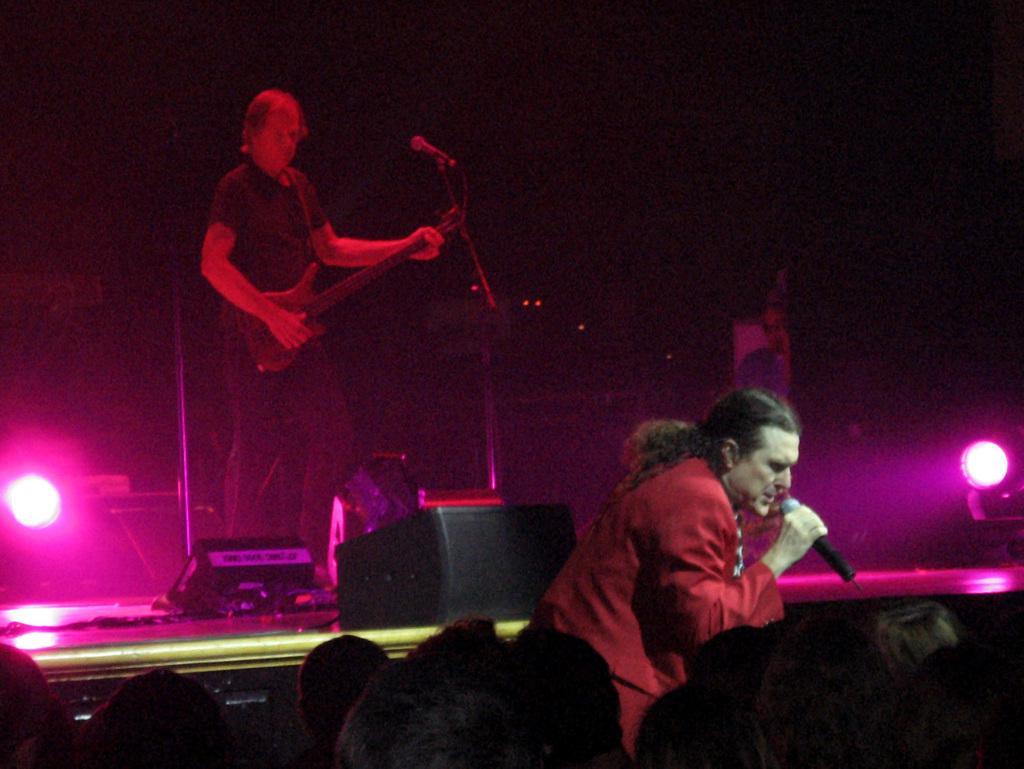How would you summarize this image in a sentence or two? In this picture i could see two persons holding a guitar and the other person holding a mic in their hand standing on the stage flash lights in the back background. In the bottom of the picture i could see some persons head. 